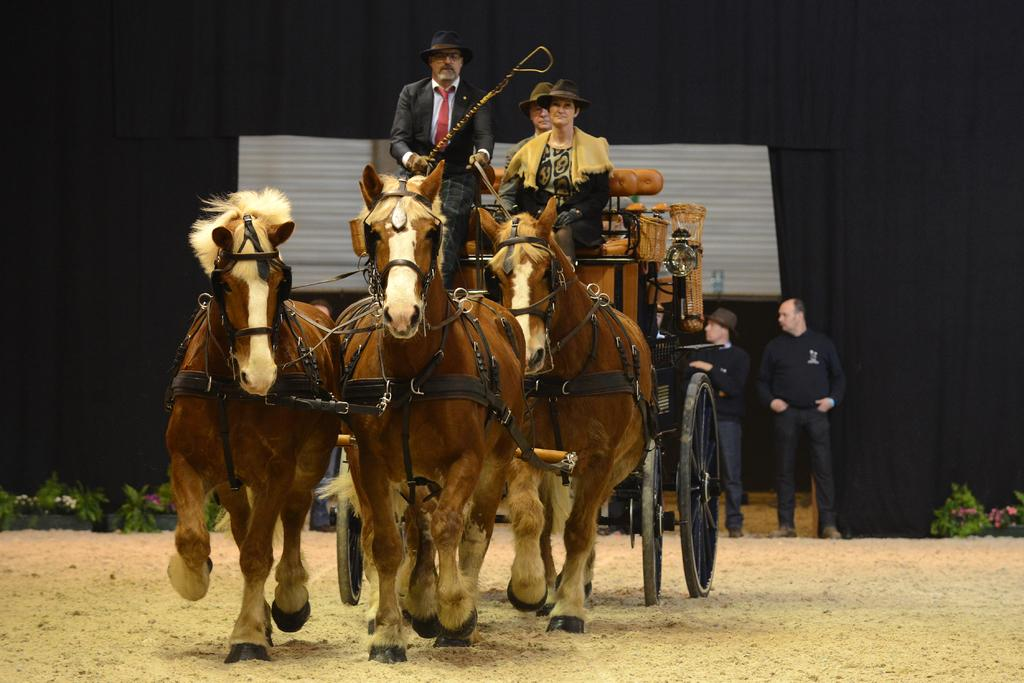What type of vehicle is in the image? There is a horse cart in the image. How many people are sitting on the horse cart? Three people are sitting on the horse cart. Are there any other people visible in the image? Yes, there are two people standing on the right side of the image. What color is the mind of the person sitting on the horse cart? There is no mention of a mind or its color in the image, as minds are not visible. 